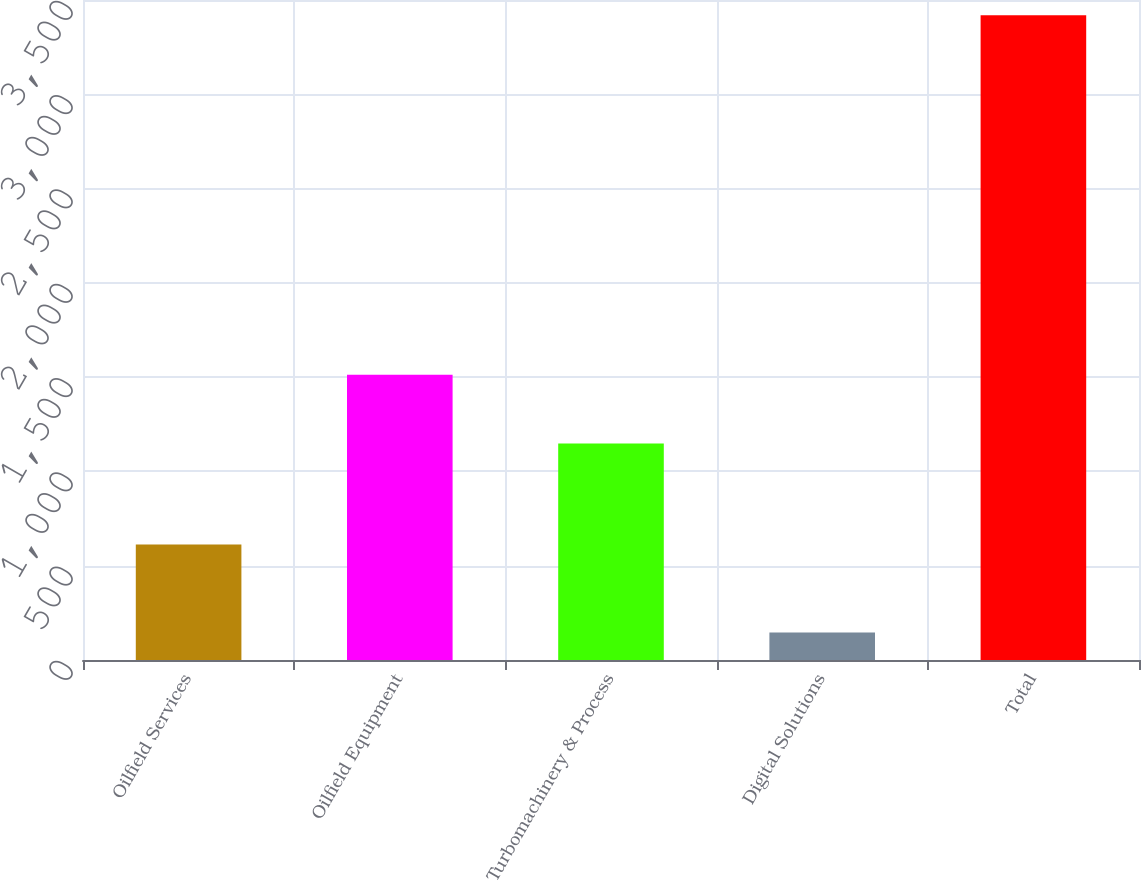Convert chart. <chart><loc_0><loc_0><loc_500><loc_500><bar_chart><fcel>Oilfield Services<fcel>Oilfield Equipment<fcel>Turbomachinery & Process<fcel>Digital Solutions<fcel>Total<nl><fcel>612<fcel>1513<fcel>1148<fcel>146<fcel>3419<nl></chart> 